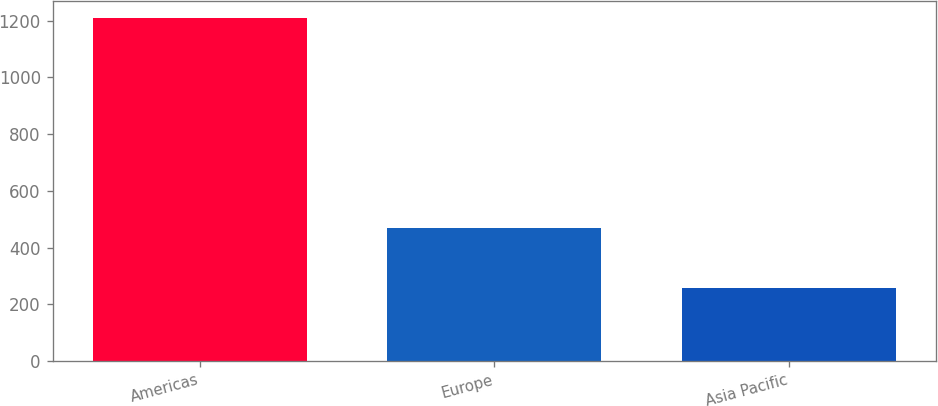Convert chart to OTSL. <chart><loc_0><loc_0><loc_500><loc_500><bar_chart><fcel>Americas<fcel>Europe<fcel>Asia Pacific<nl><fcel>1209.4<fcel>470.2<fcel>257.1<nl></chart> 